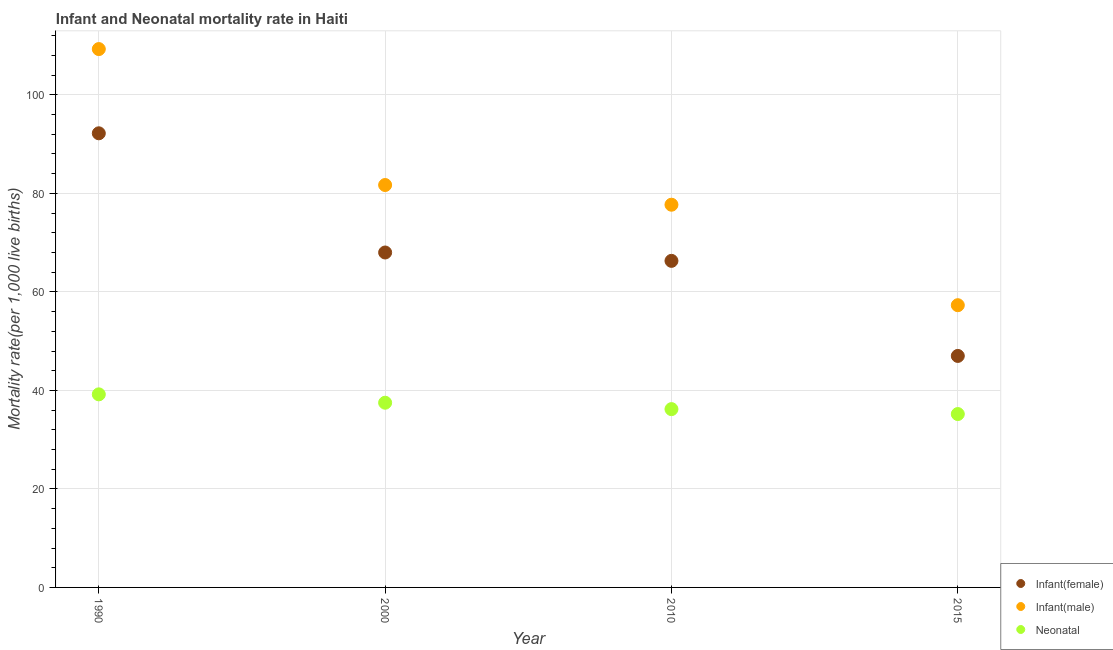Is the number of dotlines equal to the number of legend labels?
Offer a terse response. Yes. What is the infant mortality rate(male) in 2000?
Offer a terse response. 81.7. Across all years, what is the maximum neonatal mortality rate?
Make the answer very short. 39.2. Across all years, what is the minimum infant mortality rate(female)?
Provide a succinct answer. 47. In which year was the infant mortality rate(male) maximum?
Provide a short and direct response. 1990. In which year was the infant mortality rate(male) minimum?
Your answer should be compact. 2015. What is the total infant mortality rate(male) in the graph?
Give a very brief answer. 326. What is the difference between the infant mortality rate(male) in 1990 and that in 2000?
Give a very brief answer. 27.6. What is the difference between the infant mortality rate(female) in 2000 and the infant mortality rate(male) in 2015?
Your response must be concise. 10.7. What is the average infant mortality rate(male) per year?
Your response must be concise. 81.5. In the year 2010, what is the difference between the neonatal mortality rate and infant mortality rate(male)?
Keep it short and to the point. -41.5. What is the ratio of the infant mortality rate(male) in 1990 to that in 2000?
Keep it short and to the point. 1.34. Is the infant mortality rate(female) in 1990 less than that in 2010?
Make the answer very short. No. What is the difference between the highest and the second highest infant mortality rate(male)?
Offer a terse response. 27.6. Does the infant mortality rate(male) monotonically increase over the years?
Make the answer very short. No. How many dotlines are there?
Keep it short and to the point. 3. What is the difference between two consecutive major ticks on the Y-axis?
Provide a succinct answer. 20. Does the graph contain any zero values?
Your answer should be very brief. No. Does the graph contain grids?
Ensure brevity in your answer.  Yes. Where does the legend appear in the graph?
Your answer should be compact. Bottom right. What is the title of the graph?
Offer a very short reply. Infant and Neonatal mortality rate in Haiti. Does "Communicable diseases" appear as one of the legend labels in the graph?
Your response must be concise. No. What is the label or title of the Y-axis?
Keep it short and to the point. Mortality rate(per 1,0 live births). What is the Mortality rate(per 1,000 live births) of Infant(female) in 1990?
Your response must be concise. 92.2. What is the Mortality rate(per 1,000 live births) in Infant(male) in 1990?
Give a very brief answer. 109.3. What is the Mortality rate(per 1,000 live births) in Neonatal  in 1990?
Make the answer very short. 39.2. What is the Mortality rate(per 1,000 live births) in Infant(female) in 2000?
Provide a short and direct response. 68. What is the Mortality rate(per 1,000 live births) in Infant(male) in 2000?
Ensure brevity in your answer.  81.7. What is the Mortality rate(per 1,000 live births) in Neonatal  in 2000?
Your answer should be compact. 37.5. What is the Mortality rate(per 1,000 live births) of Infant(female) in 2010?
Provide a succinct answer. 66.3. What is the Mortality rate(per 1,000 live births) in Infant(male) in 2010?
Keep it short and to the point. 77.7. What is the Mortality rate(per 1,000 live births) of Neonatal  in 2010?
Offer a terse response. 36.2. What is the Mortality rate(per 1,000 live births) in Infant(female) in 2015?
Make the answer very short. 47. What is the Mortality rate(per 1,000 live births) in Infant(male) in 2015?
Your answer should be very brief. 57.3. What is the Mortality rate(per 1,000 live births) of Neonatal  in 2015?
Make the answer very short. 35.2. Across all years, what is the maximum Mortality rate(per 1,000 live births) in Infant(female)?
Give a very brief answer. 92.2. Across all years, what is the maximum Mortality rate(per 1,000 live births) of Infant(male)?
Offer a terse response. 109.3. Across all years, what is the maximum Mortality rate(per 1,000 live births) of Neonatal ?
Ensure brevity in your answer.  39.2. Across all years, what is the minimum Mortality rate(per 1,000 live births) of Infant(male)?
Provide a short and direct response. 57.3. Across all years, what is the minimum Mortality rate(per 1,000 live births) in Neonatal ?
Keep it short and to the point. 35.2. What is the total Mortality rate(per 1,000 live births) in Infant(female) in the graph?
Your answer should be very brief. 273.5. What is the total Mortality rate(per 1,000 live births) in Infant(male) in the graph?
Your answer should be compact. 326. What is the total Mortality rate(per 1,000 live births) of Neonatal  in the graph?
Keep it short and to the point. 148.1. What is the difference between the Mortality rate(per 1,000 live births) of Infant(female) in 1990 and that in 2000?
Provide a succinct answer. 24.2. What is the difference between the Mortality rate(per 1,000 live births) in Infant(male) in 1990 and that in 2000?
Keep it short and to the point. 27.6. What is the difference between the Mortality rate(per 1,000 live births) in Infant(female) in 1990 and that in 2010?
Give a very brief answer. 25.9. What is the difference between the Mortality rate(per 1,000 live births) in Infant(male) in 1990 and that in 2010?
Keep it short and to the point. 31.6. What is the difference between the Mortality rate(per 1,000 live births) of Infant(female) in 1990 and that in 2015?
Offer a terse response. 45.2. What is the difference between the Mortality rate(per 1,000 live births) in Neonatal  in 1990 and that in 2015?
Your answer should be very brief. 4. What is the difference between the Mortality rate(per 1,000 live births) in Infant(male) in 2000 and that in 2015?
Offer a terse response. 24.4. What is the difference between the Mortality rate(per 1,000 live births) of Neonatal  in 2000 and that in 2015?
Make the answer very short. 2.3. What is the difference between the Mortality rate(per 1,000 live births) in Infant(female) in 2010 and that in 2015?
Ensure brevity in your answer.  19.3. What is the difference between the Mortality rate(per 1,000 live births) in Infant(male) in 2010 and that in 2015?
Give a very brief answer. 20.4. What is the difference between the Mortality rate(per 1,000 live births) in Infant(female) in 1990 and the Mortality rate(per 1,000 live births) in Neonatal  in 2000?
Keep it short and to the point. 54.7. What is the difference between the Mortality rate(per 1,000 live births) in Infant(male) in 1990 and the Mortality rate(per 1,000 live births) in Neonatal  in 2000?
Make the answer very short. 71.8. What is the difference between the Mortality rate(per 1,000 live births) in Infant(male) in 1990 and the Mortality rate(per 1,000 live births) in Neonatal  in 2010?
Offer a very short reply. 73.1. What is the difference between the Mortality rate(per 1,000 live births) in Infant(female) in 1990 and the Mortality rate(per 1,000 live births) in Infant(male) in 2015?
Ensure brevity in your answer.  34.9. What is the difference between the Mortality rate(per 1,000 live births) of Infant(male) in 1990 and the Mortality rate(per 1,000 live births) of Neonatal  in 2015?
Provide a short and direct response. 74.1. What is the difference between the Mortality rate(per 1,000 live births) in Infant(female) in 2000 and the Mortality rate(per 1,000 live births) in Infant(male) in 2010?
Provide a short and direct response. -9.7. What is the difference between the Mortality rate(per 1,000 live births) of Infant(female) in 2000 and the Mortality rate(per 1,000 live births) of Neonatal  in 2010?
Give a very brief answer. 31.8. What is the difference between the Mortality rate(per 1,000 live births) of Infant(male) in 2000 and the Mortality rate(per 1,000 live births) of Neonatal  in 2010?
Your answer should be very brief. 45.5. What is the difference between the Mortality rate(per 1,000 live births) in Infant(female) in 2000 and the Mortality rate(per 1,000 live births) in Neonatal  in 2015?
Your answer should be very brief. 32.8. What is the difference between the Mortality rate(per 1,000 live births) of Infant(male) in 2000 and the Mortality rate(per 1,000 live births) of Neonatal  in 2015?
Offer a terse response. 46.5. What is the difference between the Mortality rate(per 1,000 live births) of Infant(female) in 2010 and the Mortality rate(per 1,000 live births) of Neonatal  in 2015?
Make the answer very short. 31.1. What is the difference between the Mortality rate(per 1,000 live births) in Infant(male) in 2010 and the Mortality rate(per 1,000 live births) in Neonatal  in 2015?
Your response must be concise. 42.5. What is the average Mortality rate(per 1,000 live births) of Infant(female) per year?
Keep it short and to the point. 68.38. What is the average Mortality rate(per 1,000 live births) in Infant(male) per year?
Offer a terse response. 81.5. What is the average Mortality rate(per 1,000 live births) in Neonatal  per year?
Provide a short and direct response. 37.02. In the year 1990, what is the difference between the Mortality rate(per 1,000 live births) of Infant(female) and Mortality rate(per 1,000 live births) of Infant(male)?
Make the answer very short. -17.1. In the year 1990, what is the difference between the Mortality rate(per 1,000 live births) in Infant(female) and Mortality rate(per 1,000 live births) in Neonatal ?
Provide a short and direct response. 53. In the year 1990, what is the difference between the Mortality rate(per 1,000 live births) of Infant(male) and Mortality rate(per 1,000 live births) of Neonatal ?
Your answer should be compact. 70.1. In the year 2000, what is the difference between the Mortality rate(per 1,000 live births) of Infant(female) and Mortality rate(per 1,000 live births) of Infant(male)?
Give a very brief answer. -13.7. In the year 2000, what is the difference between the Mortality rate(per 1,000 live births) in Infant(female) and Mortality rate(per 1,000 live births) in Neonatal ?
Offer a very short reply. 30.5. In the year 2000, what is the difference between the Mortality rate(per 1,000 live births) of Infant(male) and Mortality rate(per 1,000 live births) of Neonatal ?
Your answer should be compact. 44.2. In the year 2010, what is the difference between the Mortality rate(per 1,000 live births) of Infant(female) and Mortality rate(per 1,000 live births) of Infant(male)?
Provide a succinct answer. -11.4. In the year 2010, what is the difference between the Mortality rate(per 1,000 live births) of Infant(female) and Mortality rate(per 1,000 live births) of Neonatal ?
Keep it short and to the point. 30.1. In the year 2010, what is the difference between the Mortality rate(per 1,000 live births) of Infant(male) and Mortality rate(per 1,000 live births) of Neonatal ?
Provide a succinct answer. 41.5. In the year 2015, what is the difference between the Mortality rate(per 1,000 live births) in Infant(female) and Mortality rate(per 1,000 live births) in Infant(male)?
Provide a succinct answer. -10.3. In the year 2015, what is the difference between the Mortality rate(per 1,000 live births) of Infant(male) and Mortality rate(per 1,000 live births) of Neonatal ?
Ensure brevity in your answer.  22.1. What is the ratio of the Mortality rate(per 1,000 live births) of Infant(female) in 1990 to that in 2000?
Give a very brief answer. 1.36. What is the ratio of the Mortality rate(per 1,000 live births) of Infant(male) in 1990 to that in 2000?
Give a very brief answer. 1.34. What is the ratio of the Mortality rate(per 1,000 live births) of Neonatal  in 1990 to that in 2000?
Provide a succinct answer. 1.05. What is the ratio of the Mortality rate(per 1,000 live births) of Infant(female) in 1990 to that in 2010?
Give a very brief answer. 1.39. What is the ratio of the Mortality rate(per 1,000 live births) in Infant(male) in 1990 to that in 2010?
Keep it short and to the point. 1.41. What is the ratio of the Mortality rate(per 1,000 live births) in Neonatal  in 1990 to that in 2010?
Your answer should be very brief. 1.08. What is the ratio of the Mortality rate(per 1,000 live births) in Infant(female) in 1990 to that in 2015?
Your response must be concise. 1.96. What is the ratio of the Mortality rate(per 1,000 live births) of Infant(male) in 1990 to that in 2015?
Provide a short and direct response. 1.91. What is the ratio of the Mortality rate(per 1,000 live births) of Neonatal  in 1990 to that in 2015?
Provide a succinct answer. 1.11. What is the ratio of the Mortality rate(per 1,000 live births) of Infant(female) in 2000 to that in 2010?
Provide a short and direct response. 1.03. What is the ratio of the Mortality rate(per 1,000 live births) of Infant(male) in 2000 to that in 2010?
Provide a succinct answer. 1.05. What is the ratio of the Mortality rate(per 1,000 live births) in Neonatal  in 2000 to that in 2010?
Keep it short and to the point. 1.04. What is the ratio of the Mortality rate(per 1,000 live births) in Infant(female) in 2000 to that in 2015?
Provide a short and direct response. 1.45. What is the ratio of the Mortality rate(per 1,000 live births) of Infant(male) in 2000 to that in 2015?
Provide a short and direct response. 1.43. What is the ratio of the Mortality rate(per 1,000 live births) of Neonatal  in 2000 to that in 2015?
Offer a very short reply. 1.07. What is the ratio of the Mortality rate(per 1,000 live births) in Infant(female) in 2010 to that in 2015?
Provide a short and direct response. 1.41. What is the ratio of the Mortality rate(per 1,000 live births) in Infant(male) in 2010 to that in 2015?
Keep it short and to the point. 1.36. What is the ratio of the Mortality rate(per 1,000 live births) of Neonatal  in 2010 to that in 2015?
Offer a very short reply. 1.03. What is the difference between the highest and the second highest Mortality rate(per 1,000 live births) in Infant(female)?
Your response must be concise. 24.2. What is the difference between the highest and the second highest Mortality rate(per 1,000 live births) in Infant(male)?
Give a very brief answer. 27.6. What is the difference between the highest and the second highest Mortality rate(per 1,000 live births) of Neonatal ?
Ensure brevity in your answer.  1.7. What is the difference between the highest and the lowest Mortality rate(per 1,000 live births) of Infant(female)?
Keep it short and to the point. 45.2. 